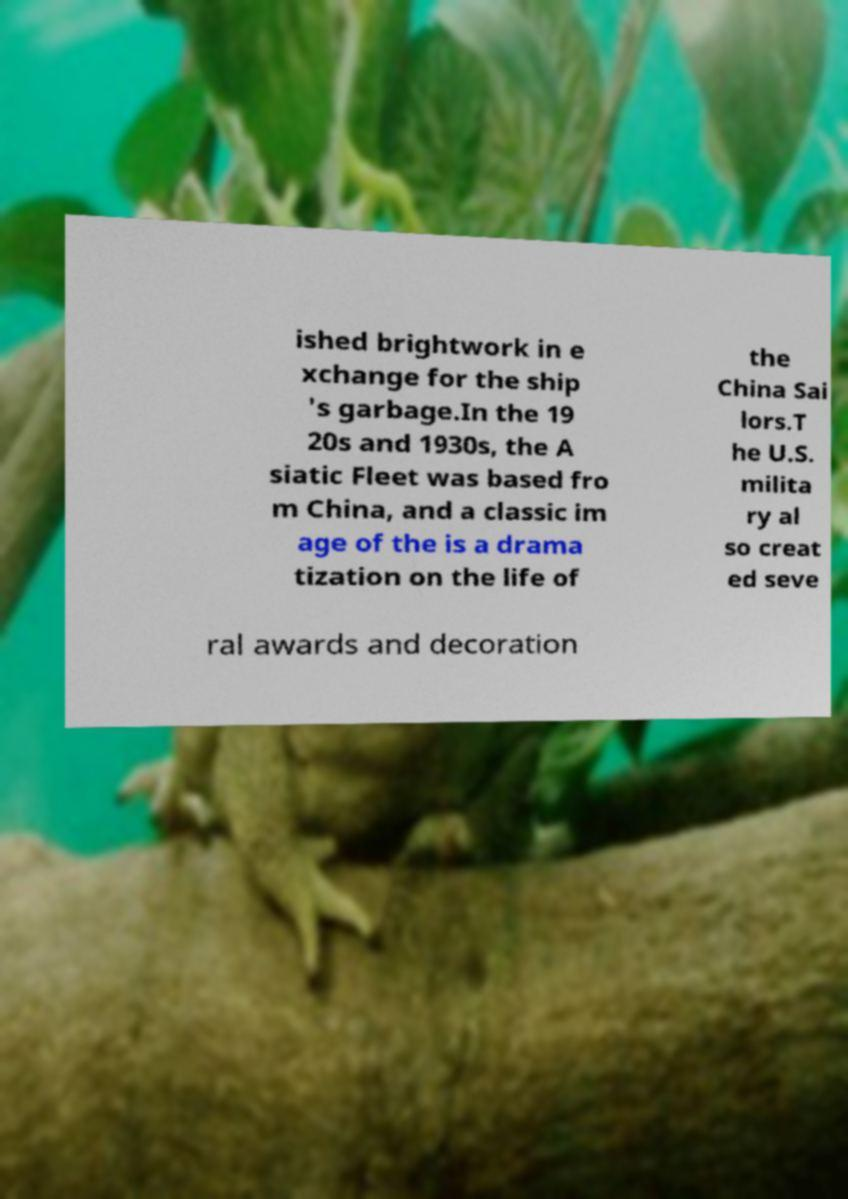What messages or text are displayed in this image? I need them in a readable, typed format. ished brightwork in e xchange for the ship 's garbage.In the 19 20s and 1930s, the A siatic Fleet was based fro m China, and a classic im age of the is a drama tization on the life of the China Sai lors.T he U.S. milita ry al so creat ed seve ral awards and decoration 